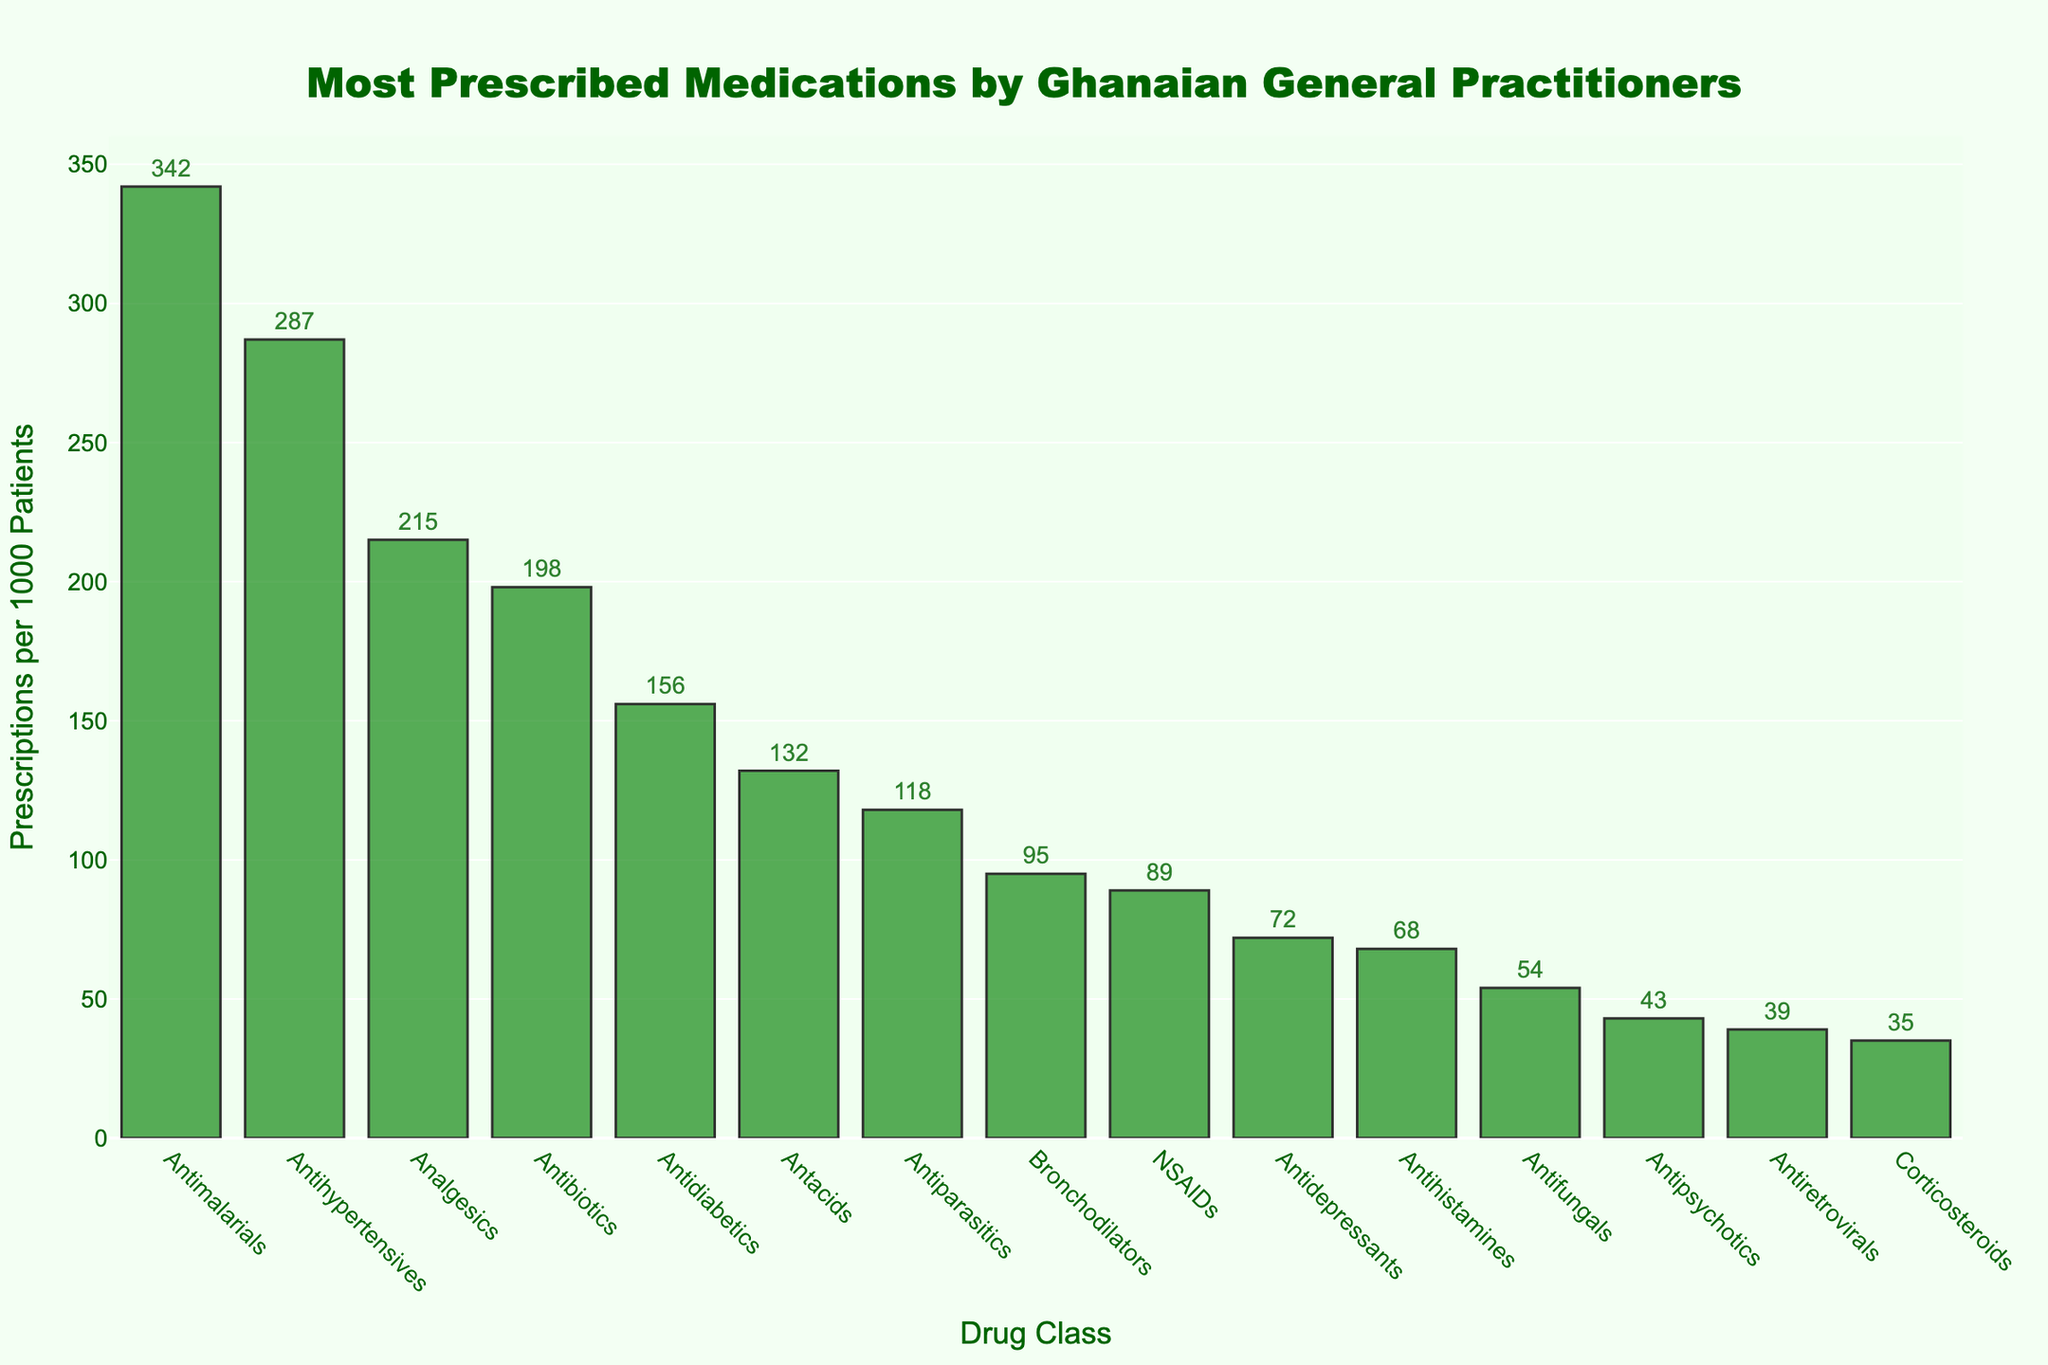Which drug class has the highest number of prescriptions per 1000 patients? Locate the tallest bar in the chart to find the drug class with the highest number of prescriptions. The Antimalarials class has the tallest bar.
Answer: Antimalarials What is the total number of prescriptions per 1000 patients for Antimalarials and Antihypertensives? Add the number of prescriptions for both drug classes: 342 (Antimalarials) + 287 (Antihypertensives) = 629.
Answer: 629 Which drug class has fewer prescriptions per 1000 patients: Analgesics or Antidiabetics? Compare the height of the bars for Analgesics (215) and Antidiabetics (156). Antidiabetics has fewer prescriptions.
Answer: Antidiabetics What is the difference in the number of prescriptions per 1000 patients between Antibiotics and Bronchodilators? Subtract the number of prescriptions for Bronchodilators (95) from that of Antibiotics (198): 198 - 95 = 103.
Answer: 103 How many more prescriptions per 1000 patients do Antacids have compared to NSAIDs? Subtract the number of prescriptions for NSAIDs (89) from that of Antacids (132): 132 - 89 = 43.
Answer: 43 What is the average number of prescriptions per 1000 patients for Antidepressants, Antihistamines, and Antifungals? Add the number of prescriptions for the three classes and divide by 3: (72 + 68 + 54) / 3 = 64.67.
Answer: 64.67 Which drug class is prescribed the least often per 1000 patients? Locate the shortest bar in the chart to find the drug class with the fewest prescriptions. The Corticosteroids class has the shortest bar.
Answer: Corticosteroids Are Antipsychotics prescribed more or less often than Antiretrovirals per 1000 patients? Compare the height of the bars for Antipsychotics (43) and Antiretrovirals (39). Antipsychotics have more prescriptions per 1000 patients.
Answer: More What is the median number of prescriptions per 1000 patients for all the drug classes? List all numbers and find the middle value: 35, 39, 43, 54, 68, 72, 89, 95, 118, 132, 156, 198, 215, 287, 342. The median is the 8th number: 95.
Answer: 95 Which drug classes have between 50 and 100 prescriptions per 1000 patients? Identify and list the drug classes with the number of prescriptions in the specified range: Bronchodilators (95), NSAIDs (89), Antidepressants (72), Antihistamines (68), Antifungals (54).
Answer: Bronchodilators, NSAIDs, Antidepressants, Antihistamines, Antifungals 